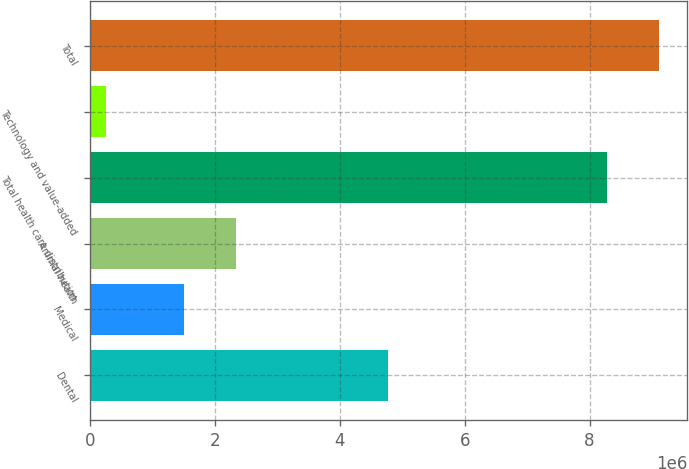Convert chart to OTSL. <chart><loc_0><loc_0><loc_500><loc_500><bar_chart><fcel>Dental<fcel>Medical<fcel>Animal health<fcel>Total health care distribution<fcel>Technology and value-added<fcel>Total<nl><fcel>4.7649e+06<fcel>1.50445e+06<fcel>2.33242e+06<fcel>8.27962e+06<fcel>250620<fcel>9.10758e+06<nl></chart> 